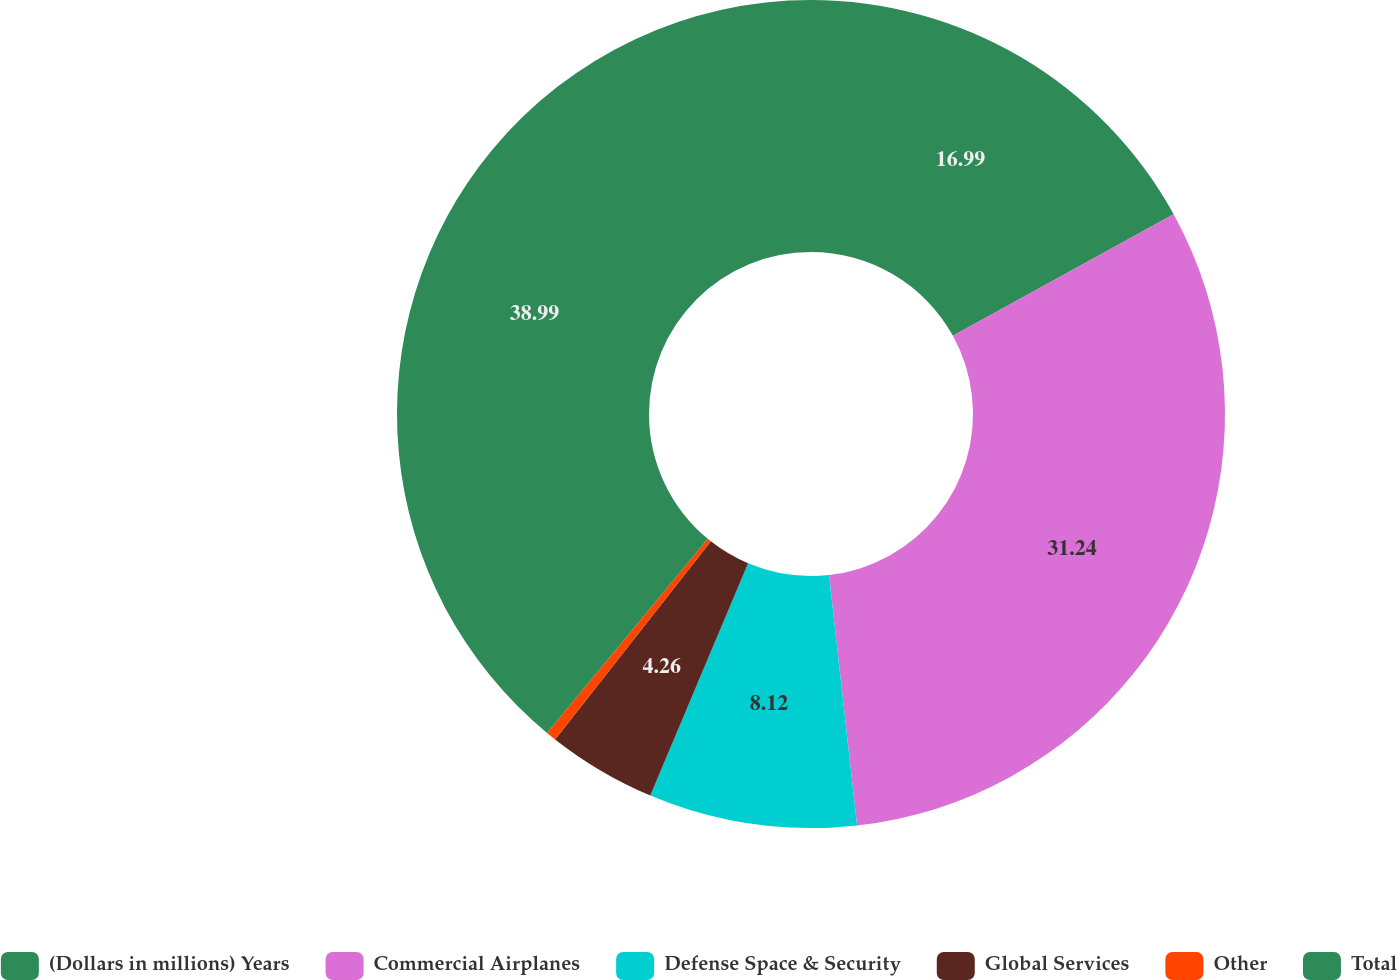Convert chart to OTSL. <chart><loc_0><loc_0><loc_500><loc_500><pie_chart><fcel>(Dollars in millions) Years<fcel>Commercial Airplanes<fcel>Defense Space & Security<fcel>Global Services<fcel>Other<fcel>Total<nl><fcel>16.99%<fcel>31.24%<fcel>8.12%<fcel>4.26%<fcel>0.4%<fcel>39.0%<nl></chart> 